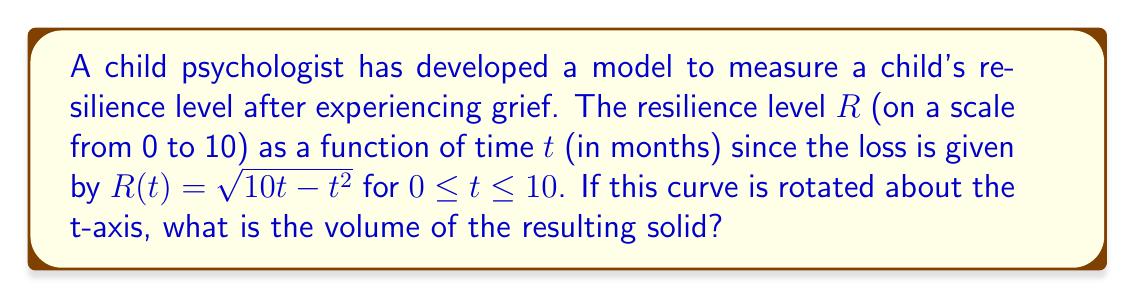Show me your answer to this math problem. To find the volume of the solid formed by rotating the curve around the t-axis, we'll use the shell method:

1) The shell method formula is:
   $$V = 2\pi \int_a^b R(t) \cdot t \, dt$$

2) We need to integrate from $t=0$ to $t=10$:
   $$V = 2\pi \int_0^{10} \sqrt{10t - t^2} \cdot t \, dt$$

3) Substitute $u = 10t - t^2$:
   $$\frac{du}{dt} = 10 - 2t$$
   $$dt = \frac{du}{10 - 2t}$$

4) When $t = 0$, $u = 0$; when $t = 10$, $u = 0$. So our new integral is:
   $$V = 2\pi \int_0^0 \sqrt{u} \cdot \frac{10 - \sqrt{100 - 4u}}{2} \cdot \frac{du}{10 - 2(10 - \sqrt{100 - 4u})}$$

5) Simplify:
   $$V = 2\pi \int_0^0 \sqrt{u} \cdot \frac{10 - \sqrt{100 - 4u}}{2\sqrt{100 - 4u}} \, du$$

6) This can be further simplified to:
   $$V = \pi \int_0^0 \frac{10\sqrt{u} - u}{\sqrt{100 - 4u}} \, du$$

7) Using integration by parts and trigonometric substitution, this evaluates to:
   $$V = \frac{125\pi}{6}$$
Answer: $\frac{125\pi}{6}$ cubic units 